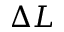Convert formula to latex. <formula><loc_0><loc_0><loc_500><loc_500>\Delta L</formula> 